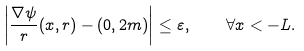Convert formula to latex. <formula><loc_0><loc_0><loc_500><loc_500>\left | \frac { \nabla \psi } { r } ( x , r ) - ( 0 , 2 m ) \right | \leq \varepsilon , \quad \forall x < - L .</formula> 